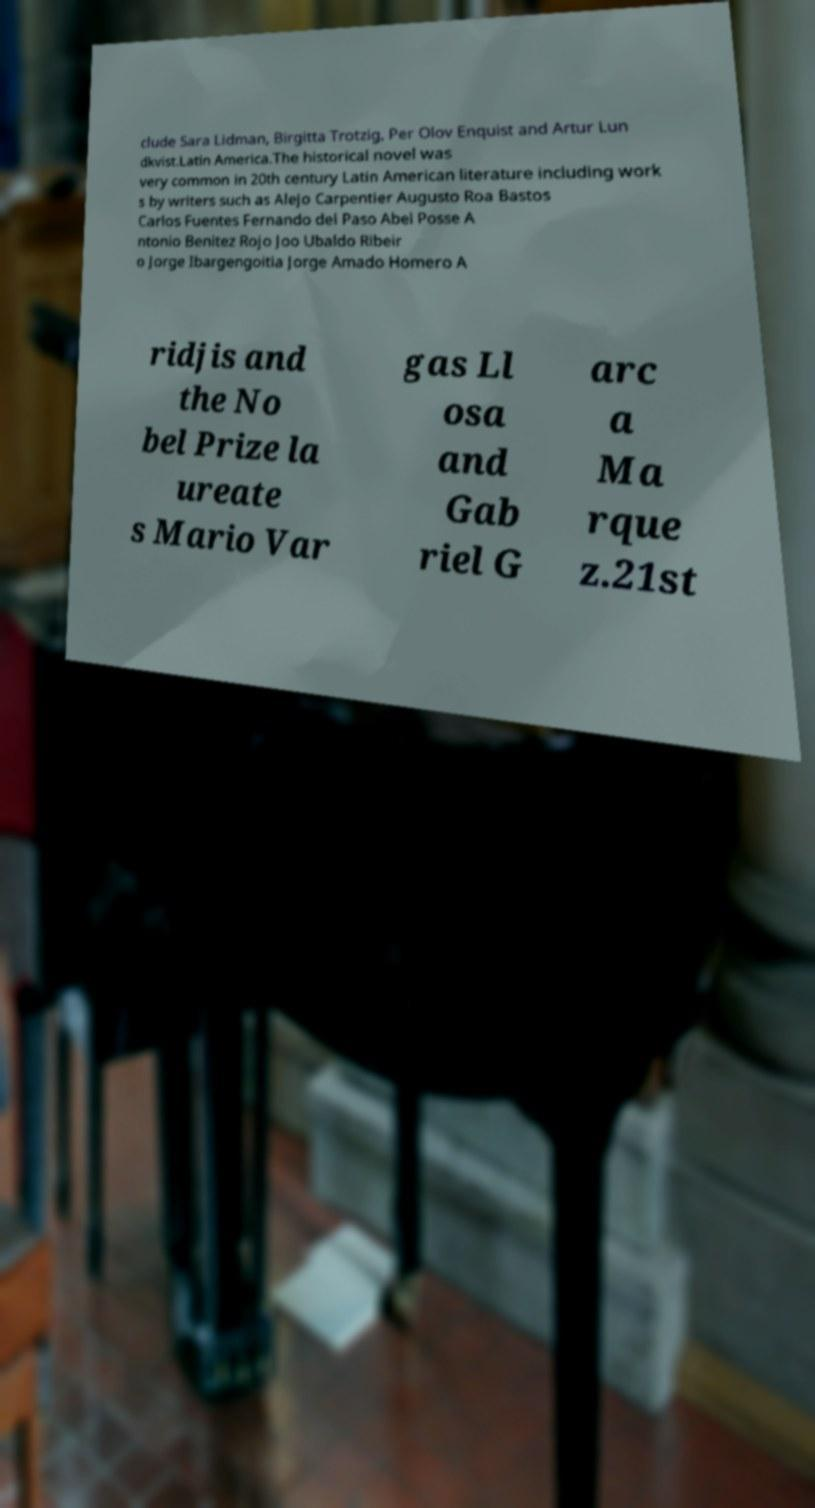I need the written content from this picture converted into text. Can you do that? clude Sara Lidman, Birgitta Trotzig, Per Olov Enquist and Artur Lun dkvist.Latin America.The historical novel was very common in 20th century Latin American literature including work s by writers such as Alejo Carpentier Augusto Roa Bastos Carlos Fuentes Fernando del Paso Abel Posse A ntonio Benitez Rojo Joo Ubaldo Ribeir o Jorge Ibargengoitia Jorge Amado Homero A ridjis and the No bel Prize la ureate s Mario Var gas Ll osa and Gab riel G arc a Ma rque z.21st 